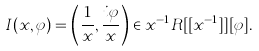<formula> <loc_0><loc_0><loc_500><loc_500>I ( x , \varphi ) = \left ( \frac { 1 } { x } , \frac { i \varphi } { x } \right ) \in x ^ { - 1 } R [ [ x ^ { - 1 } ] ] [ \varphi ] .</formula> 